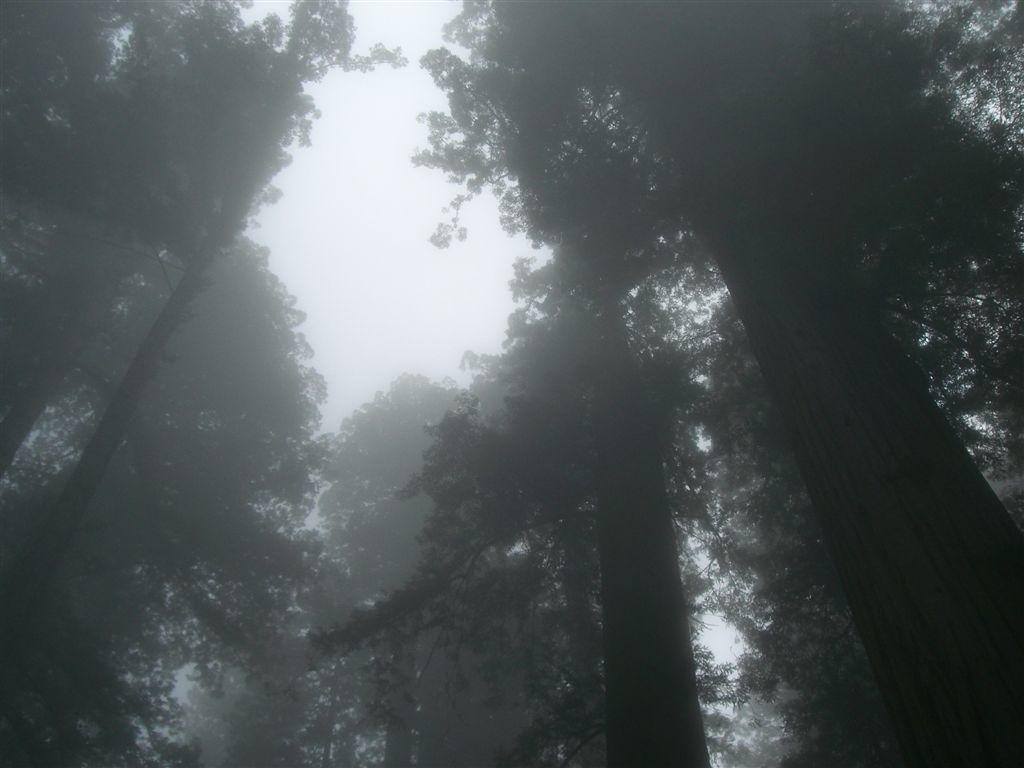What type of vegetation can be seen in the image? There are trees in the image. What part of the natural environment is visible in the image? The sky is visible in the image. How many geese are standing near the hydrant in the image? There is no hydrant or geese present in the image. What type of tank can be seen in the image? There is no tank present in the image. 